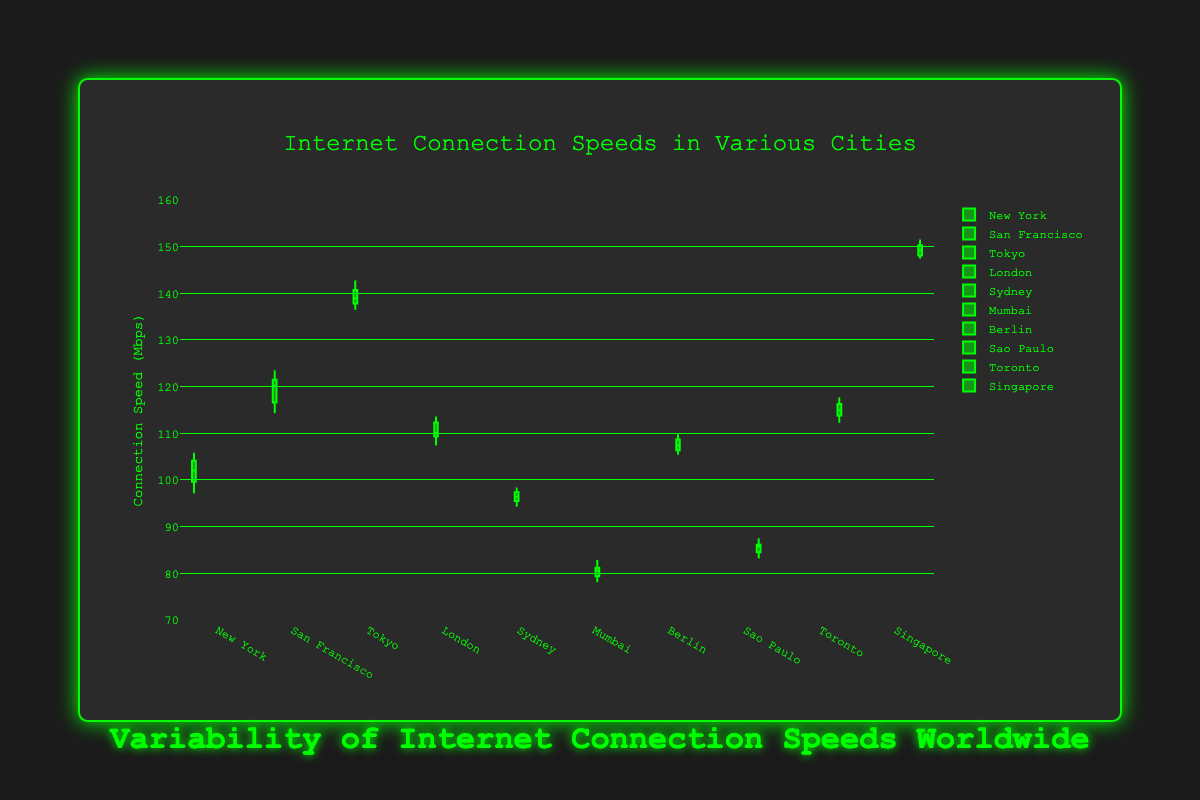Which city has the highest median internet connection speed? To find the city with the highest median internet connection speed, you need to compare the median line (the line inside the box) for each city's box plot. Singapore has the highest median as its median line is the highest among all cities.
Answer: Singapore What is the range of internet connection speeds in Sydney? The range of a box plot is determined by the difference between the maximum and minimum points (whiskers). For Sydney, the maximum is 98.2 Mbps and the minimum is 94.5 Mbps. The range is \(98.2 - 94.5 = 3.7\) Mbps.
Answer: 3.7 Mbps Which city has the smallest variability in internet connection speeds? Variability in a box plot is indicated by the size of the box (interquartile range). Looking at all the box plots, Tokyo has the smallest box, implying it has the least variability in internet connection speeds.
Answer: Tokyo Compare the median internet connection speeds between New York and London. Which city has a higher median speed? To compare medians, look at the median lines in their respective box plots. New York's median line is slightly lower compared to London's. Therefore, London has a higher median internet connection speed.
Answer: London What is the highest recorded internet speed in Tokyo? The highest recorded speed is indicated by the topmost point (whisker) in the box plot for Tokyo. This value is 142.6 Mbps.
Answer: 142.6 Mbps How does the interquartile range (IQR) of San Francisco compare to that of Mumbai? The IQR can be seen as the size of the box in the box plot. San Francisco's box is larger than Mumbai's box, indicating that San Francisco has a larger IQR and thus more variability within the middle 50% of its data points.
Answer: San Francisco has a larger IQR Which city shows the highest maximum internet speed and what is its value? The highest maximum value in the box plots is observed by looking at the topmost whisker among all cities. Singapore's top whisker reaches 151.3 Mbps, which is the highest maximum speed.
Answer: Singapore, 151.3 Mbps What is the median internet connection speed in Sao Paulo? The median value is the middle line of the box in the box plot for Sao Paulo. It lies roughly at 85.7 Mbps.
Answer: 85.7 Mbps Which city has the highest lower whisker (minimum value) excluding the outliers, and what is the value? The lower whisker represents the minimum value, excluding outliers. Comparing all box plots, Toronto has the highest lower whisker at approximately 112.5 Mbps.
Answer: Toronto, 112.5 Mbps Compare the variability of internet connection speeds between Berlin and Tokyo. Which city shows more consistency? To compare the variability, look at the size of the boxes (IQR) and the length of the whiskers. Tokyo's IQR is smaller, and its whiskers are shorter compared to Berlin’s, indicating that Tokyo has more consistent internet speeds.
Answer: Tokyo 